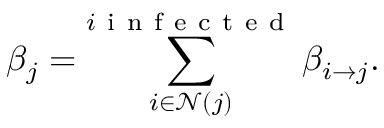<formula> <loc_0><loc_0><loc_500><loc_500>\beta _ { j } = \sum _ { i \in \mathcal { N } ( j ) } ^ { i i n f e c t e d } \beta _ { i \to j } .</formula> 